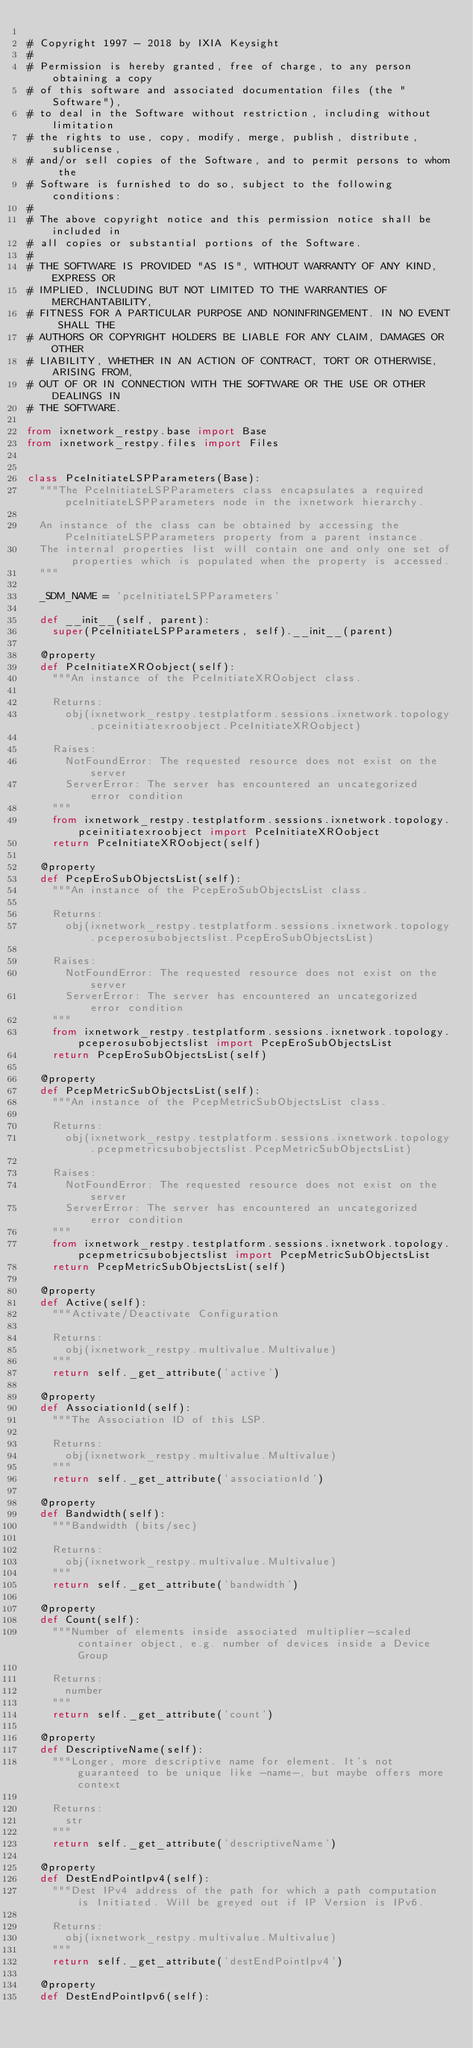<code> <loc_0><loc_0><loc_500><loc_500><_Python_>
# Copyright 1997 - 2018 by IXIA Keysight
#
# Permission is hereby granted, free of charge, to any person obtaining a copy
# of this software and associated documentation files (the "Software"),
# to deal in the Software without restriction, including without limitation
# the rights to use, copy, modify, merge, publish, distribute, sublicense,
# and/or sell copies of the Software, and to permit persons to whom the
# Software is furnished to do so, subject to the following conditions:
#
# The above copyright notice and this permission notice shall be included in
# all copies or substantial portions of the Software.
#
# THE SOFTWARE IS PROVIDED "AS IS", WITHOUT WARRANTY OF ANY KIND, EXPRESS OR
# IMPLIED, INCLUDING BUT NOT LIMITED TO THE WARRANTIES OF MERCHANTABILITY,
# FITNESS FOR A PARTICULAR PURPOSE AND NONINFRINGEMENT. IN NO EVENT SHALL THE
# AUTHORS OR COPYRIGHT HOLDERS BE LIABLE FOR ANY CLAIM, DAMAGES OR OTHER
# LIABILITY, WHETHER IN AN ACTION OF CONTRACT, TORT OR OTHERWISE, ARISING FROM,
# OUT OF OR IN CONNECTION WITH THE SOFTWARE OR THE USE OR OTHER DEALINGS IN
# THE SOFTWARE.
    
from ixnetwork_restpy.base import Base
from ixnetwork_restpy.files import Files


class PceInitiateLSPParameters(Base):
	"""The PceInitiateLSPParameters class encapsulates a required pceInitiateLSPParameters node in the ixnetwork hierarchy.

	An instance of the class can be obtained by accessing the PceInitiateLSPParameters property from a parent instance.
	The internal properties list will contain one and only one set of properties which is populated when the property is accessed.
	"""

	_SDM_NAME = 'pceInitiateLSPParameters'

	def __init__(self, parent):
		super(PceInitiateLSPParameters, self).__init__(parent)

	@property
	def PceInitiateXROobject(self):
		"""An instance of the PceInitiateXROobject class.

		Returns:
			obj(ixnetwork_restpy.testplatform.sessions.ixnetwork.topology.pceinitiatexroobject.PceInitiateXROobject)

		Raises:
			NotFoundError: The requested resource does not exist on the server
			ServerError: The server has encountered an uncategorized error condition
		"""
		from ixnetwork_restpy.testplatform.sessions.ixnetwork.topology.pceinitiatexroobject import PceInitiateXROobject
		return PceInitiateXROobject(self)

	@property
	def PcepEroSubObjectsList(self):
		"""An instance of the PcepEroSubObjectsList class.

		Returns:
			obj(ixnetwork_restpy.testplatform.sessions.ixnetwork.topology.pceperosubobjectslist.PcepEroSubObjectsList)

		Raises:
			NotFoundError: The requested resource does not exist on the server
			ServerError: The server has encountered an uncategorized error condition
		"""
		from ixnetwork_restpy.testplatform.sessions.ixnetwork.topology.pceperosubobjectslist import PcepEroSubObjectsList
		return PcepEroSubObjectsList(self)

	@property
	def PcepMetricSubObjectsList(self):
		"""An instance of the PcepMetricSubObjectsList class.

		Returns:
			obj(ixnetwork_restpy.testplatform.sessions.ixnetwork.topology.pcepmetricsubobjectslist.PcepMetricSubObjectsList)

		Raises:
			NotFoundError: The requested resource does not exist on the server
			ServerError: The server has encountered an uncategorized error condition
		"""
		from ixnetwork_restpy.testplatform.sessions.ixnetwork.topology.pcepmetricsubobjectslist import PcepMetricSubObjectsList
		return PcepMetricSubObjectsList(self)

	@property
	def Active(self):
		"""Activate/Deactivate Configuration

		Returns:
			obj(ixnetwork_restpy.multivalue.Multivalue)
		"""
		return self._get_attribute('active')

	@property
	def AssociationId(self):
		"""The Association ID of this LSP.

		Returns:
			obj(ixnetwork_restpy.multivalue.Multivalue)
		"""
		return self._get_attribute('associationId')

	@property
	def Bandwidth(self):
		"""Bandwidth (bits/sec)

		Returns:
			obj(ixnetwork_restpy.multivalue.Multivalue)
		"""
		return self._get_attribute('bandwidth')

	@property
	def Count(self):
		"""Number of elements inside associated multiplier-scaled container object, e.g. number of devices inside a Device Group

		Returns:
			number
		"""
		return self._get_attribute('count')

	@property
	def DescriptiveName(self):
		"""Longer, more descriptive name for element. It's not guaranteed to be unique like -name-, but maybe offers more context

		Returns:
			str
		"""
		return self._get_attribute('descriptiveName')

	@property
	def DestEndPointIpv4(self):
		"""Dest IPv4 address of the path for which a path computation is Initiated. Will be greyed out if IP Version is IPv6.

		Returns:
			obj(ixnetwork_restpy.multivalue.Multivalue)
		"""
		return self._get_attribute('destEndPointIpv4')

	@property
	def DestEndPointIpv6(self):</code> 